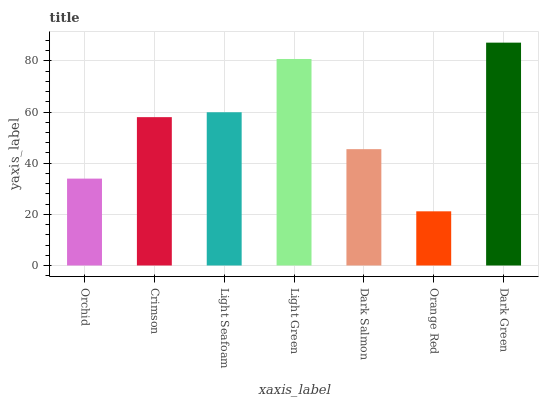Is Orange Red the minimum?
Answer yes or no. Yes. Is Dark Green the maximum?
Answer yes or no. Yes. Is Crimson the minimum?
Answer yes or no. No. Is Crimson the maximum?
Answer yes or no. No. Is Crimson greater than Orchid?
Answer yes or no. Yes. Is Orchid less than Crimson?
Answer yes or no. Yes. Is Orchid greater than Crimson?
Answer yes or no. No. Is Crimson less than Orchid?
Answer yes or no. No. Is Crimson the high median?
Answer yes or no. Yes. Is Crimson the low median?
Answer yes or no. Yes. Is Dark Green the high median?
Answer yes or no. No. Is Dark Green the low median?
Answer yes or no. No. 